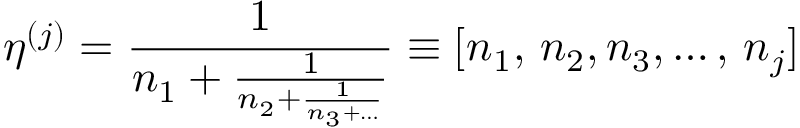<formula> <loc_0><loc_0><loc_500><loc_500>\eta ^ { ( j ) } = \frac { 1 } { n _ { 1 } + \frac { 1 } { n _ { 2 } + \frac { 1 } { n _ { 3 } + \dots } } } \equiv [ n _ { 1 } , \, n _ { 2 } , n _ { 3 } , \dots , \, n _ { j } ]</formula> 